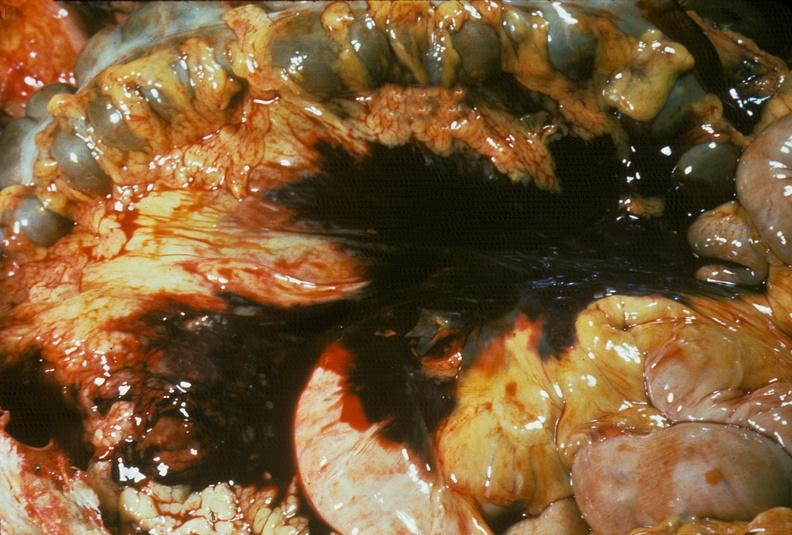what does this image show?
Answer the question using a single word or phrase. Hemorrhage secondary to ruptured aneurysm 